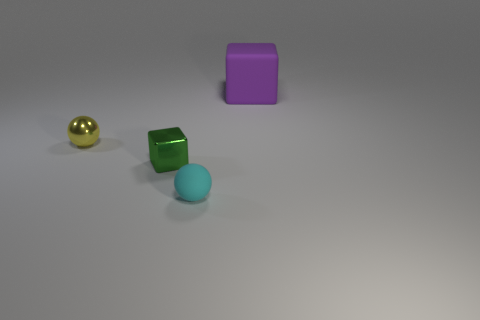Add 3 tiny shiny spheres. How many objects exist? 7 Subtract 1 cubes. How many cubes are left? 1 Subtract all yellow matte cubes. Subtract all big matte things. How many objects are left? 3 Add 3 purple blocks. How many purple blocks are left? 4 Add 2 metallic blocks. How many metallic blocks exist? 3 Subtract 0 cyan cubes. How many objects are left? 4 Subtract all brown spheres. Subtract all yellow cubes. How many spheres are left? 2 Subtract all cyan cylinders. How many green spheres are left? 0 